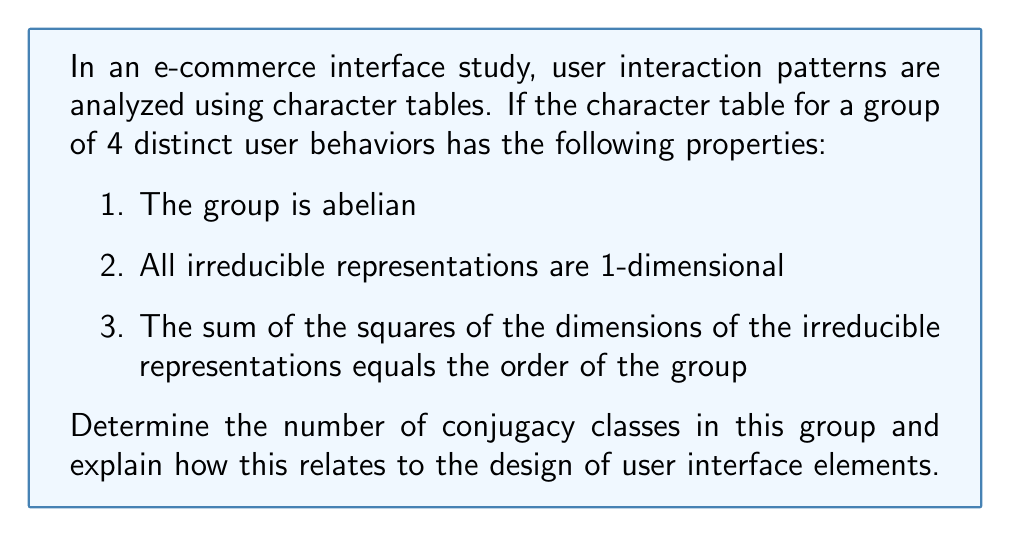Give your solution to this math problem. Let's approach this step-by-step:

1) For abelian groups, the number of irreducible representations is equal to the number of conjugacy classes.

2) Given that all irreducible representations are 1-dimensional, let's call the number of irreducible representations (and conjugacy classes) $n$.

3) The sum of squares of dimensions of irreducible representations equals the order of the group. We can express this as:

   $$\sum_{i=1}^n d_i^2 = |G|$$

   where $d_i$ is the dimension of the $i$-th irreducible representation and $|G|$ is the order of the group.

4) Since all representations are 1-dimensional, $d_i = 1$ for all $i$. Therefore:

   $$\sum_{i=1}^n 1^2 = |G|$$

5) This simplifies to:

   $$n = |G|$$

6) We're told that there are 4 distinct user behaviors, which corresponds to the order of the group. Therefore:

   $$n = |G| = 4$$

7) In terms of UI design, this means we have 4 distinct user interaction patterns that don't overlap or combine. Each pattern corresponds to a conjugacy class and an irreducible representation.

8) For an e-commerce interface, this could translate to 4 distinct user journey types, each requiring a unique design approach. For example:
   - Quick purchase
   - Detailed product research
   - Comparison shopping
   - Browsing without immediate intent to purchase

9) Understanding these distinct patterns allows designers to create tailored interface elements and flows for each user behavior, potentially improving the overall user experience and conversion rates.
Answer: 4 conjugacy classes 